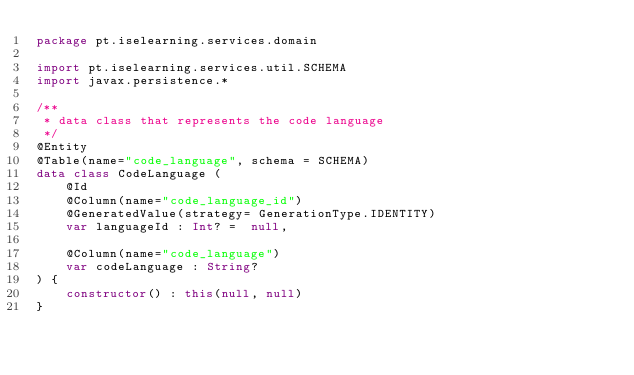Convert code to text. <code><loc_0><loc_0><loc_500><loc_500><_Kotlin_>package pt.iselearning.services.domain

import pt.iselearning.services.util.SCHEMA
import javax.persistence.*

/**
 * data class that represents the code language
 */
@Entity
@Table(name="code_language", schema = SCHEMA)
data class CodeLanguage (
    @Id
    @Column(name="code_language_id")
    @GeneratedValue(strategy= GenerationType.IDENTITY)
    var languageId : Int? =  null,

    @Column(name="code_language")
    var codeLanguage : String?
) {
    constructor() : this(null, null)
}
</code> 